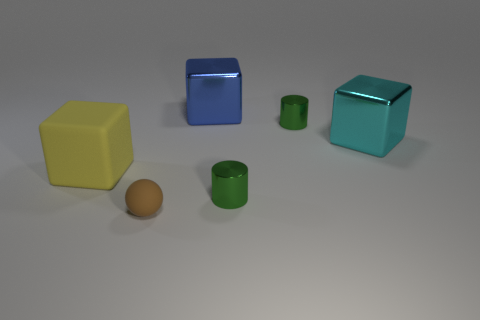What material is the object right of the cylinder that is behind the thing that is to the left of the brown matte ball? The object to the right of the cylinder, positioned behind the item to the left of the brown matte ball, appears to be made of a reflective material, likely metal, due to its shiny surface and sharp reflections. 